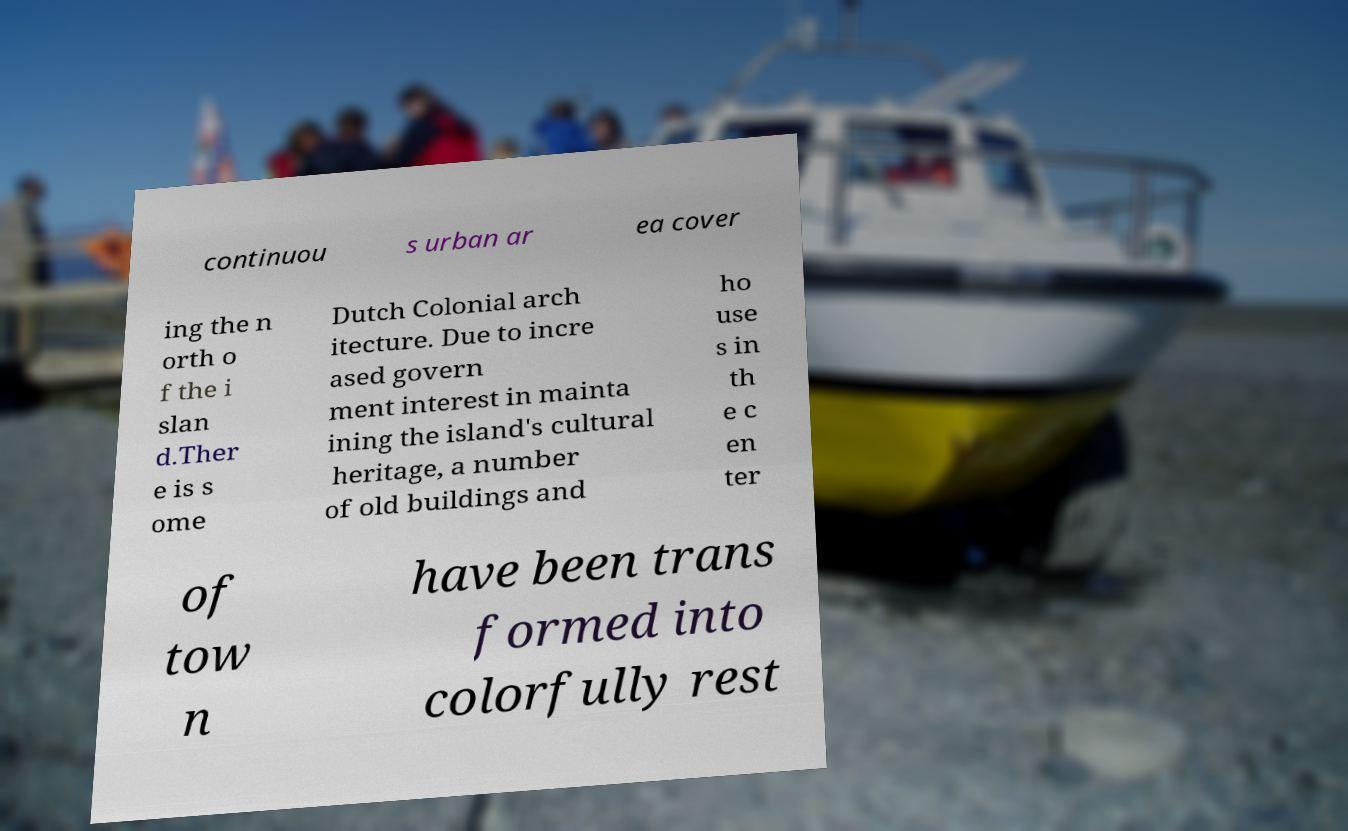Could you assist in decoding the text presented in this image and type it out clearly? continuou s urban ar ea cover ing the n orth o f the i slan d.Ther e is s ome Dutch Colonial arch itecture. Due to incre ased govern ment interest in mainta ining the island's cultural heritage, a number of old buildings and ho use s in th e c en ter of tow n have been trans formed into colorfully rest 